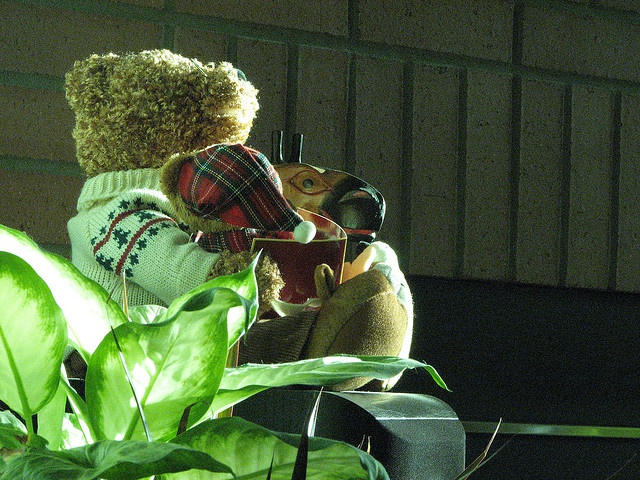Describe the objects in this image and their specific colors. I can see a teddy bear in black, darkgreen, lightgreen, and green tones in this image. 